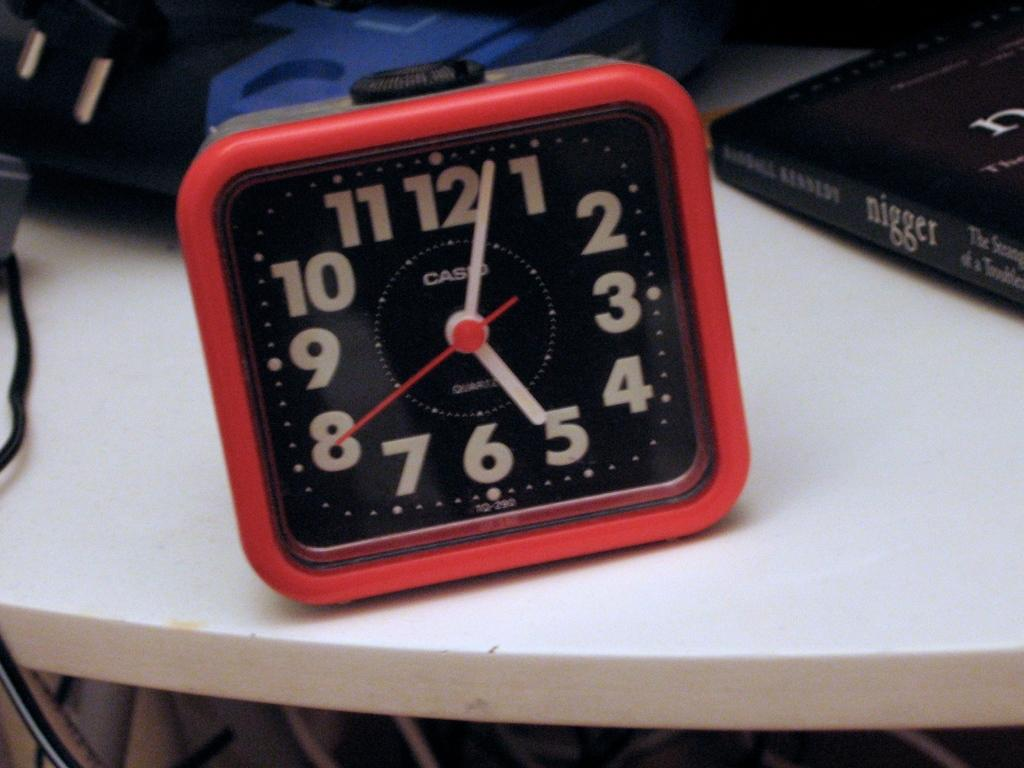<image>
Offer a succinct explanation of the picture presented. the numbers 1 to 12 that are on a clock 